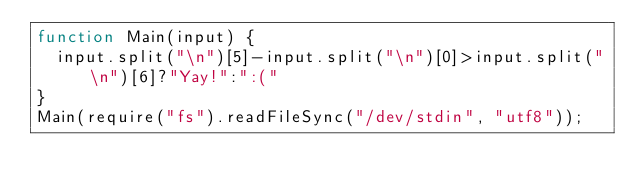Convert code to text. <code><loc_0><loc_0><loc_500><loc_500><_JavaScript_>function Main(input) {
  input.split("\n")[5]-input.split("\n")[0]>input.split("\n")[6]?"Yay!":":("
}
Main(require("fs").readFileSync("/dev/stdin", "utf8"));</code> 